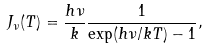<formula> <loc_0><loc_0><loc_500><loc_500>J _ { \nu } ( T ) = \frac { h \nu } { k } \frac { 1 } { \exp ( h \nu / k T ) - 1 } ,</formula> 